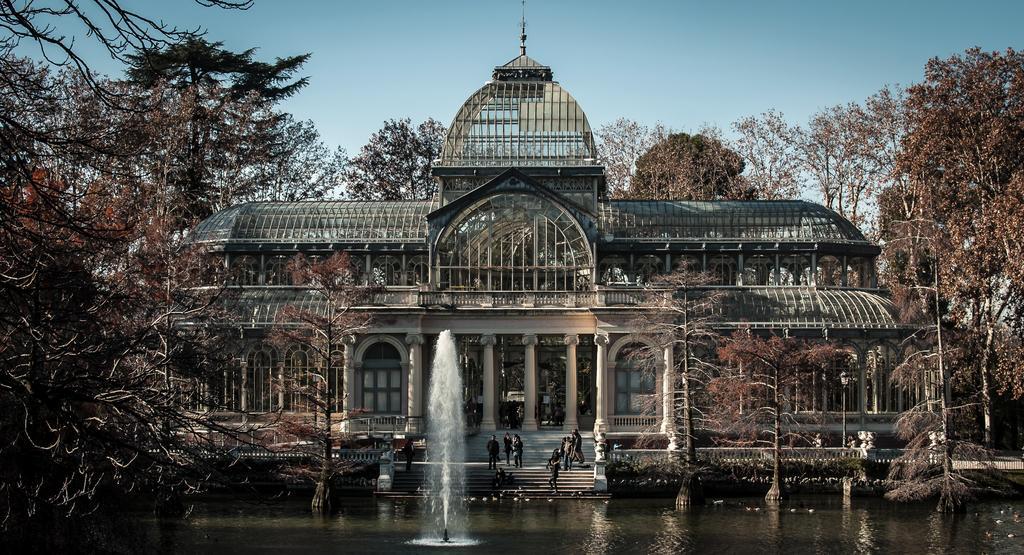Describe this image in one or two sentences. This picture contains a building. In front of that, we see people standing on the staircase. At the bottom of the picture, we see water and a fountain. There are many trees in the background. At the top of the picture, we see the sky. 